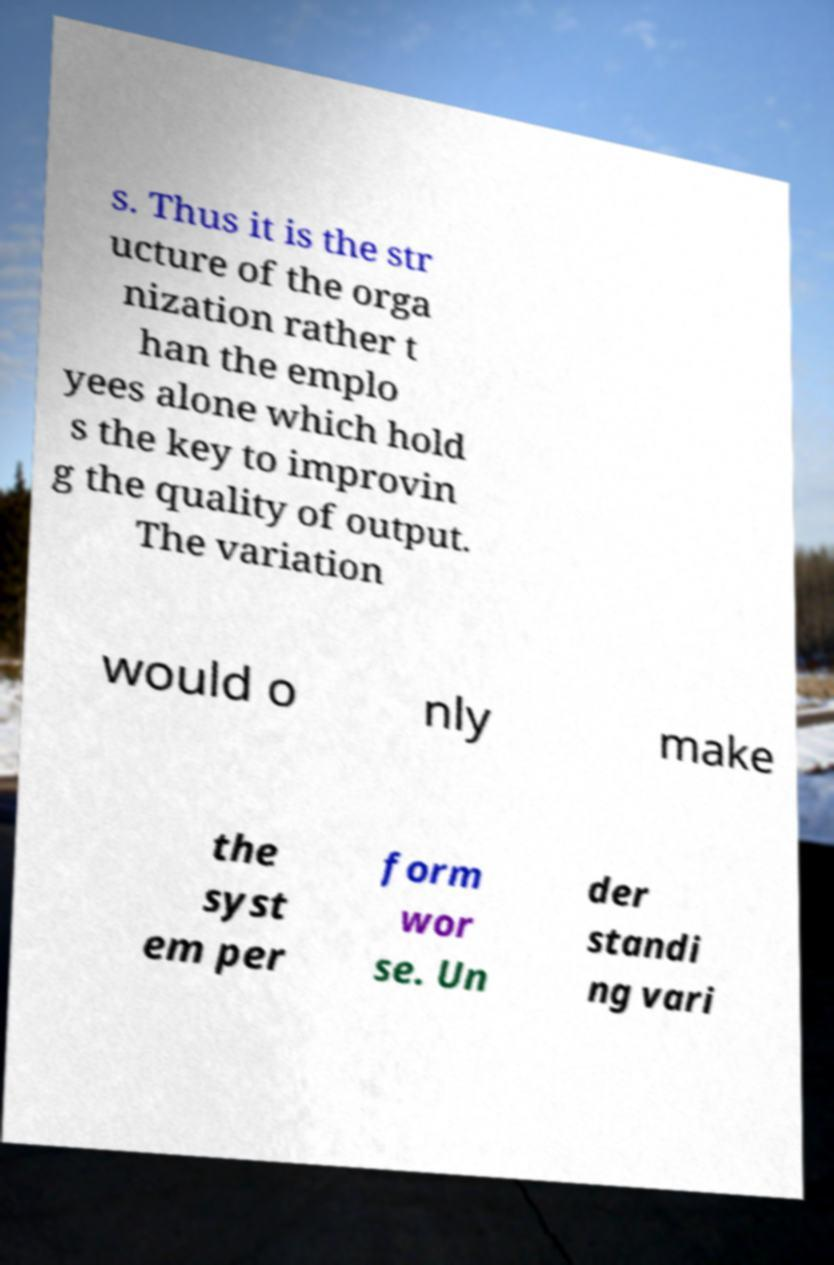Could you extract and type out the text from this image? s. Thus it is the str ucture of the orga nization rather t han the emplo yees alone which hold s the key to improvin g the quality of output. The variation would o nly make the syst em per form wor se. Un der standi ng vari 